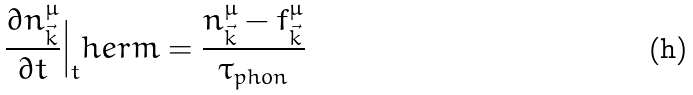Convert formula to latex. <formula><loc_0><loc_0><loc_500><loc_500>\frac { \partial n ^ { \mu } _ { \vec { k } } } { \partial t } \Big | _ { t } h e r m = \frac { n ^ { \mu } _ { \vec { k } } - f ^ { \mu } _ { \vec { k } } } { \tau _ { p h o n } }</formula> 